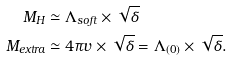Convert formula to latex. <formula><loc_0><loc_0><loc_500><loc_500>M _ { H } & \simeq \Lambda _ { s o f t } \times \sqrt { \delta } \\ M _ { e x t r a } & \simeq 4 \pi v \times \sqrt { \delta } = \Lambda _ { ( 0 ) } \times \sqrt { \delta } .</formula> 